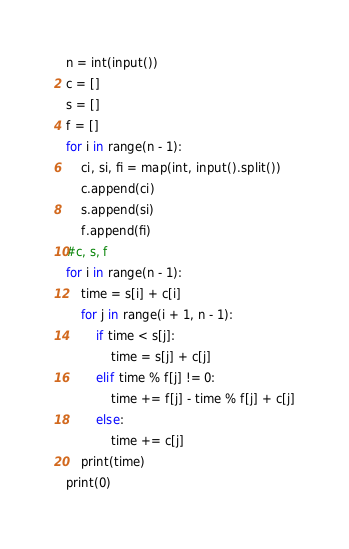<code> <loc_0><loc_0><loc_500><loc_500><_Python_>n = int(input())
c = []
s = []
f = []
for i in range(n - 1):
    ci, si, fi = map(int, input().split())
    c.append(ci)
    s.append(si)
    f.append(fi)
#c, s, f
for i in range(n - 1):
    time = s[i] + c[i]
    for j in range(i + 1, n - 1):
        if time < s[j]:
            time = s[j] + c[j]
        elif time % f[j] != 0:
            time += f[j] - time % f[j] + c[j]
        else:
            time += c[j]
    print(time)
print(0)</code> 